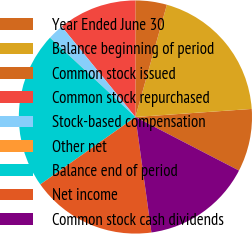Convert chart to OTSL. <chart><loc_0><loc_0><loc_500><loc_500><pie_chart><fcel>Year Ended June 30<fcel>Balance beginning of period<fcel>Common stock issued<fcel>Common stock repurchased<fcel>Stock-based compensation<fcel>Other net<fcel>Balance end of period<fcel>Net income<fcel>Common stock cash dividends<nl><fcel>8.7%<fcel>19.55%<fcel>4.36%<fcel>10.87%<fcel>2.19%<fcel>0.02%<fcel>21.72%<fcel>17.38%<fcel>15.21%<nl></chart> 